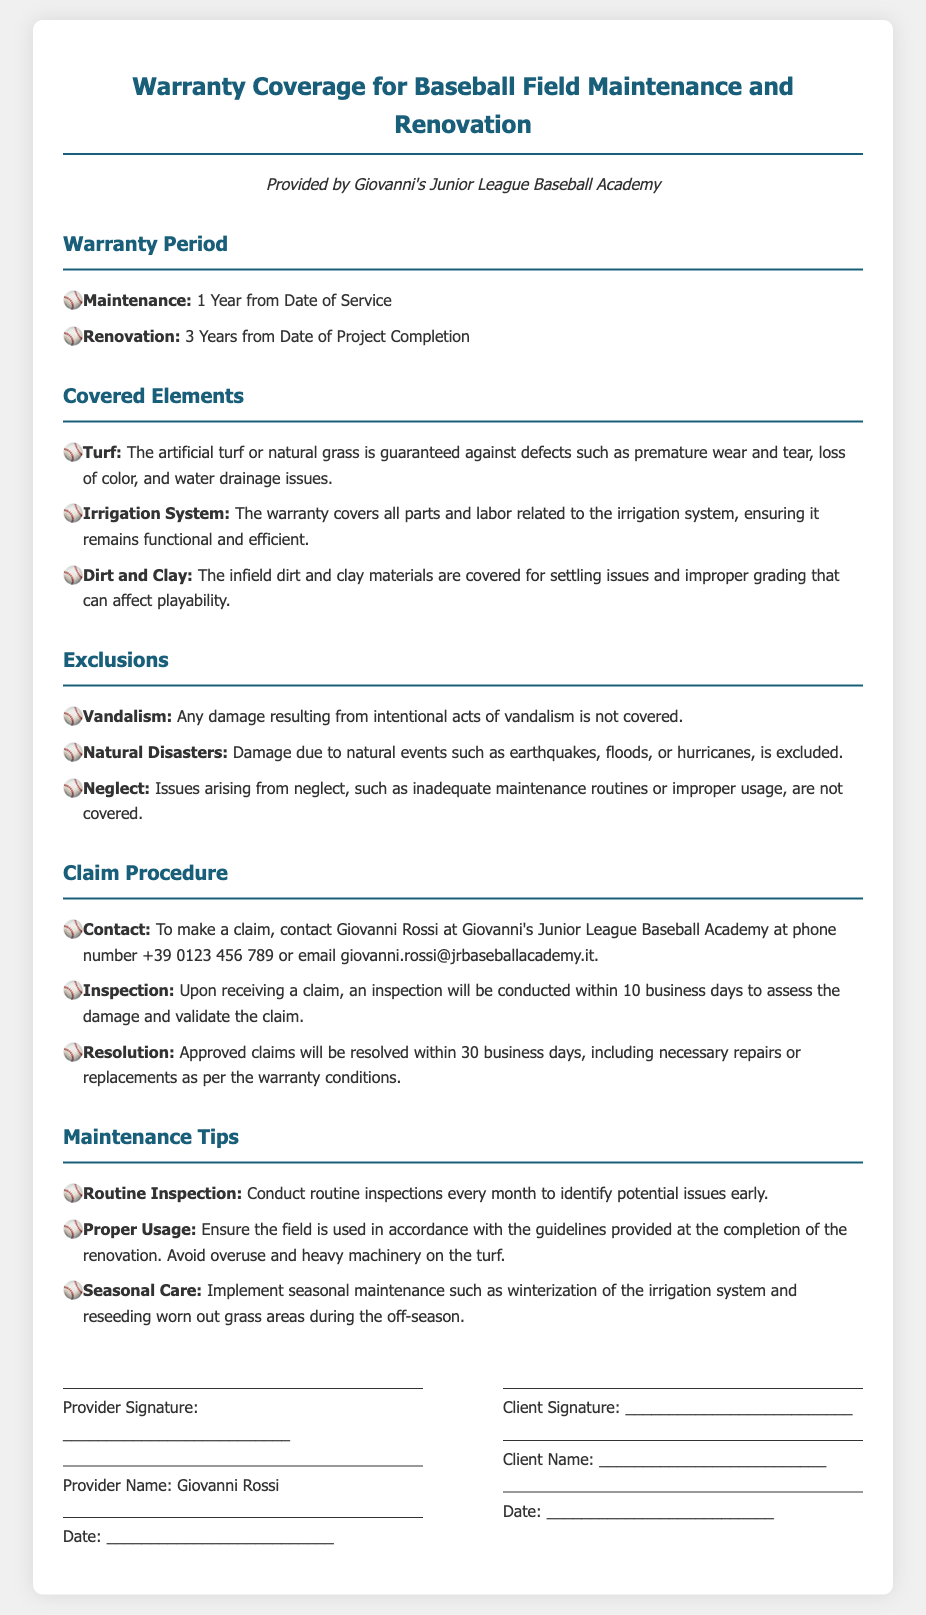What is the warranty period for maintenance? The warranty period for maintenance is specified under the "Warranty Period" section as 1 Year from Date of Service.
Answer: 1 Year What is the warranty period for renovation? The warranty period for renovation is specified under the "Warranty Period" section as 3 Years from Date of Project Completion.
Answer: 3 Years Who is the provider of the warranty? The provider of the warranty is mentioned in the subtitle and is Giovanni's Junior League Baseball Academy.
Answer: Giovanni's Junior League Baseball Academy What items are covered under the warranty? The covered elements include turf, irrigation system, and dirt and clay as specified under the "Covered Elements" section.
Answer: Turf, Irrigation System, Dirt and Clay What is excluded from the warranty coverage? The document lists exclusions under the "Exclusions" section, including vandalism, natural disasters, and neglect.
Answer: Vandalism, Natural Disasters, Neglect How long do you have to make a claim after noticing an issue? The claim procedure does not explicitly mention a time limit for making a claim, but it states an inspection will occur within 10 business days after the claim is made.
Answer: 10 business days What is the phone number to contact for claims? The contact information for claims includes a phone number, which is listed in the "Claim Procedure" section.
Answer: +39 0123 456 789 What is the resolution time for approved claims? The document states that approved claims will be resolved within 30 business days, as indicated in the "Claim Procedure" section.
Answer: 30 business days What maintenance tip involves seasonal care? The "Maintenance Tips" section contains tips and mentions seasonal care such as winterization of the irrigation system and reseeding grass areas.
Answer: Seasonal Care 